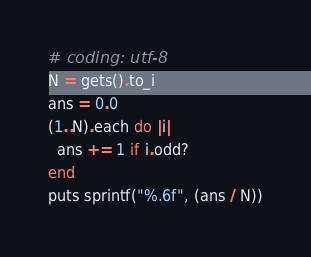<code> <loc_0><loc_0><loc_500><loc_500><_Ruby_># coding: utf-8
N = gets().to_i
ans = 0.0
(1..N).each do |i|
  ans += 1 if i.odd?
end
puts sprintf("%.6f", (ans / N))
</code> 